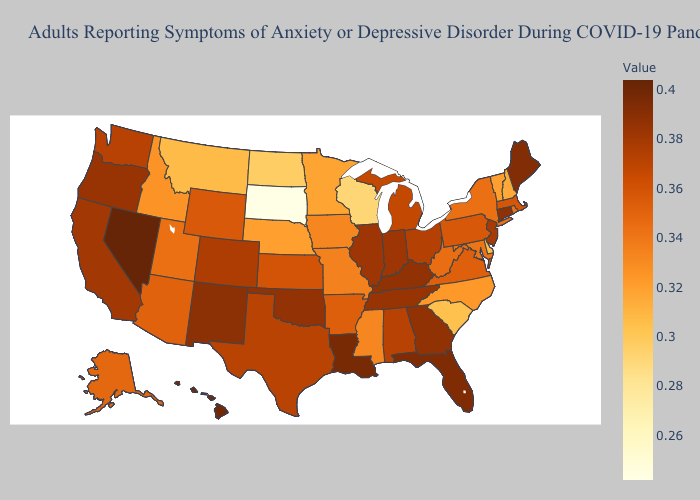Does North Carolina have the highest value in the USA?
Keep it brief. No. Which states hav the highest value in the South?
Give a very brief answer. Louisiana. Among the states that border Utah , does Idaho have the highest value?
Short answer required. No. Which states hav the highest value in the South?
Write a very short answer. Louisiana. Among the states that border Nevada , which have the highest value?
Give a very brief answer. Oregon. Which states have the lowest value in the USA?
Write a very short answer. South Dakota. Among the states that border North Dakota , does Minnesota have the highest value?
Concise answer only. Yes. 